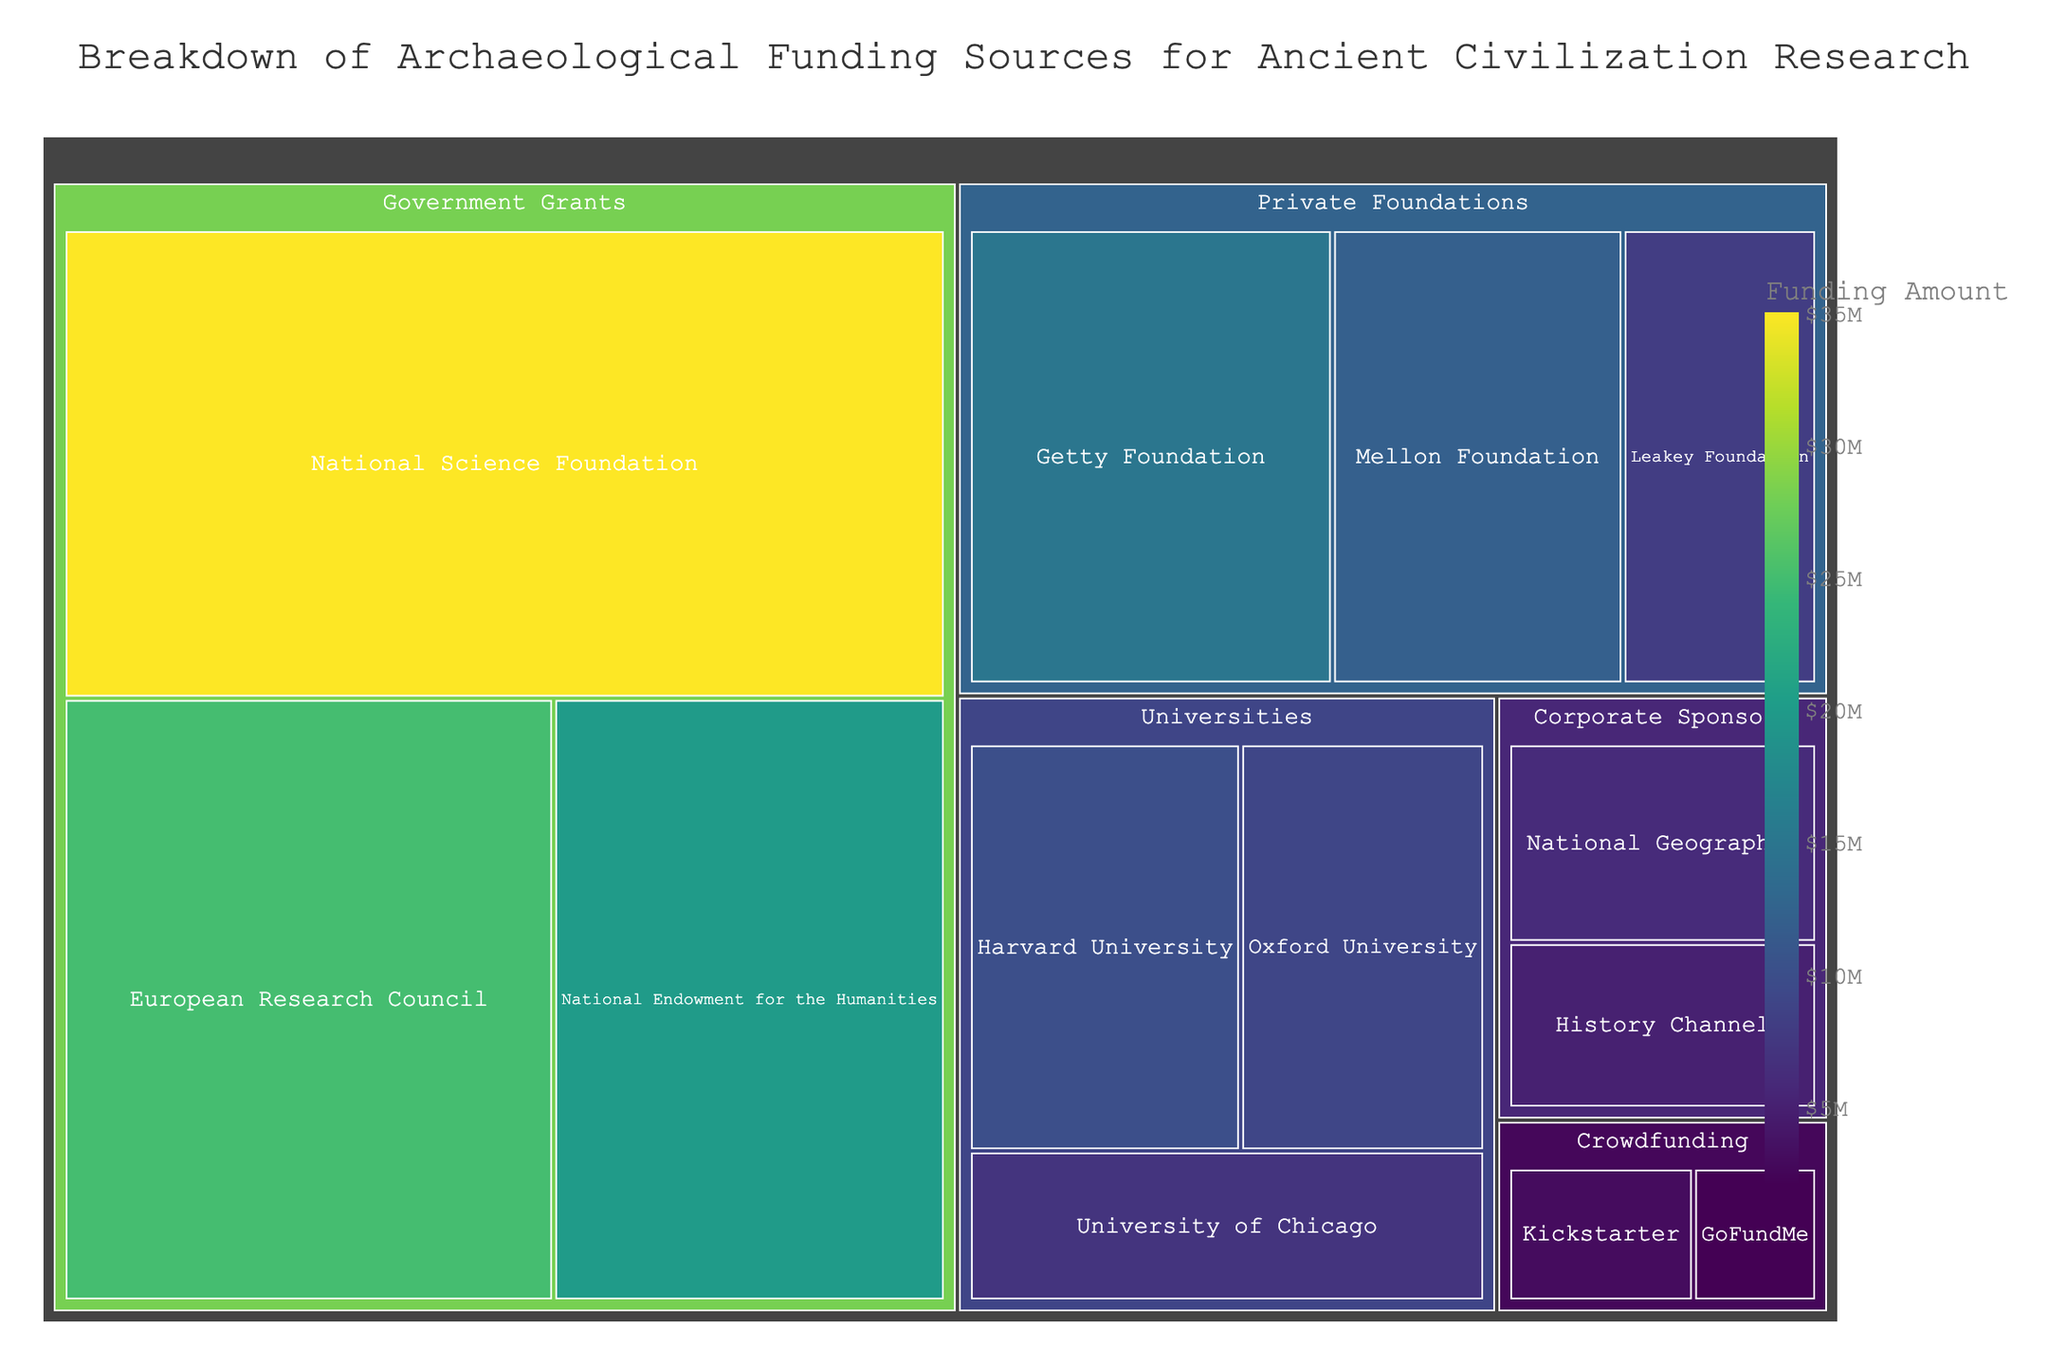What is the largest funding source for archaeological research in this figure? The largest funding source is visually represented by the largest section of the treemap. In this case, "National Science Foundation" in the "Government Grants" category has the largest area.
Answer: National Science Foundation How many funding sources come from corporate sponsors? In the "Corporate Sponsors" category of the treemap, there are two subcategories: "History Channel" and "National Geographic".
Answer: 2 What is the total amount of government grants for archaeological research? Add the values for each subcategory under "Government Grants": National Science Foundation (35) + National Endowment for the Humanities (20) + European Research Council (25) = 80.
Answer: $80M Which category has the smallest overall funding, and what is the total amount? Compare the sums of all subcategories in each category. The "Crowdfunding" category has the smallest overall funding: Kickstarter (3) + GoFundMe (2) = 5.
Answer: Crowdfunding, $5M How does the funding amount of Harvard University compare to that of Oxford University? Compare the values directly: Harvard University (10) has a larger amount than Oxford University (9).
Answer: Harvard University has more funding What is the combined funding from the Getty Foundation and the Mellon Foundation? Add the values: Getty Foundation (15) + Mellon Foundation (12) = 27.
Answer: $27M Which private foundation provides the least funding, and how much is it? Within the "Private Foundations" category, compare the values of all subcategories: Leakey Foundation (8) is the smallest.
Answer: Leakey Foundation, $8M How much more funding does the National Science Foundation have compared to the European Research Council? Subtract the value of the European Research Council from the National Science Foundation: 35 - 25 = 10.
Answer: $10M What is the total funding from the National Geographic and History Channel combined? Add the values: National Geographic (6) + History Channel (5) = 11.
Answer: $11M 